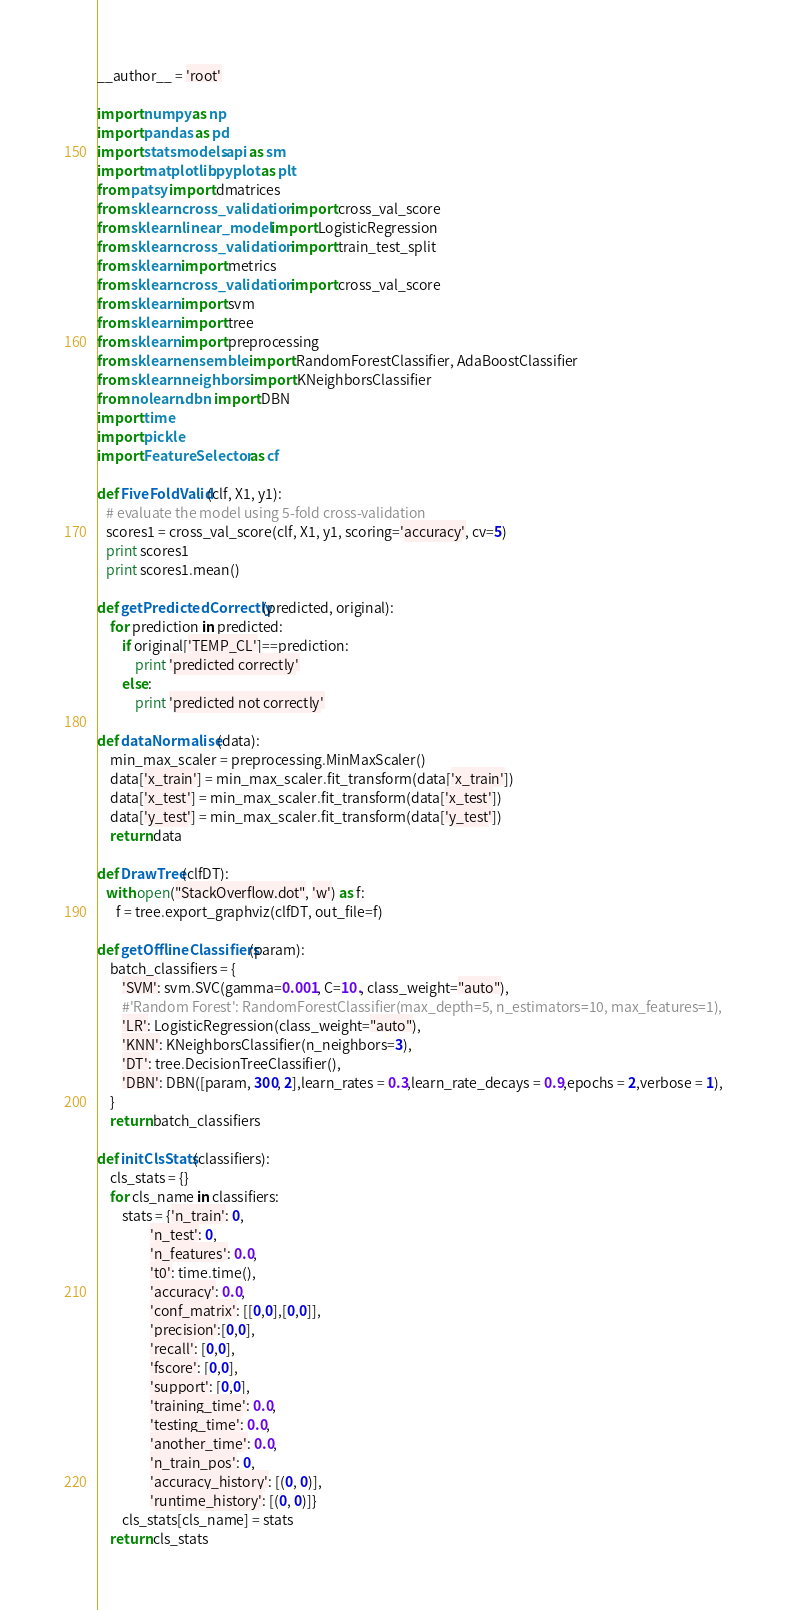Convert code to text. <code><loc_0><loc_0><loc_500><loc_500><_Python_>__author__ = 'root'

import numpy as np
import pandas as pd
import statsmodels.api as sm
import matplotlib.pyplot as plt
from patsy import dmatrices
from sklearn.cross_validation import cross_val_score
from sklearn.linear_model import LogisticRegression
from sklearn.cross_validation import train_test_split
from sklearn import metrics
from sklearn.cross_validation import cross_val_score
from sklearn import svm
from sklearn import tree
from sklearn import preprocessing
from sklearn.ensemble import RandomForestClassifier, AdaBoostClassifier
from sklearn.neighbors import KNeighborsClassifier
from nolearn.dbn import DBN
import time
import pickle
import FeatureSelector as cf

def FiveFoldValid(clf, X1, y1):
   # evaluate the model using 5-fold cross-validation
   scores1 = cross_val_score(clf, X1, y1, scoring='accuracy', cv=5)
   print scores1
   print scores1.mean()

def getPredictedCorrectly(predicted, original):
    for prediction in predicted:
        if original['TEMP_CL']==prediction:
            print 'predicted correctly'
        else:
            print 'predicted not correctly'

def dataNormalise(data):
    min_max_scaler = preprocessing.MinMaxScaler()
    data['x_train'] = min_max_scaler.fit_transform(data['x_train'])
    data['x_test'] = min_max_scaler.fit_transform(data['x_test'])
    data['y_test'] = min_max_scaler.fit_transform(data['y_test'])
    return data

def DrawTree(clfDT):
   with open("StackOverflow.dot", 'w') as f:
      f = tree.export_graphviz(clfDT, out_file=f)

def getOfflineClassifiers(param):
    batch_classifiers = {
        'SVM': svm.SVC(gamma=0.001, C=10., class_weight="auto"),
        #'Random Forest': RandomForestClassifier(max_depth=5, n_estimators=10, max_features=1),
        'LR': LogisticRegression(class_weight="auto"),
        'KNN': KNeighborsClassifier(n_neighbors=3),
        'DT': tree.DecisionTreeClassifier(),
        'DBN': DBN([param, 300, 2],learn_rates = 0.3,learn_rate_decays = 0.9,epochs = 2,verbose = 1),
    }
    return batch_classifiers

def initClsStats(classifiers):
    cls_stats = {}
    for cls_name in classifiers:
        stats = {'n_train': 0,
                 'n_test': 0,
                 'n_features': 0.0,
                 't0': time.time(),
                 'accuracy': 0.0,
                 'conf_matrix': [[0,0],[0,0]],
                 'precision':[0,0],
                 'recall': [0,0],
                 'fscore': [0,0],
                 'support': [0,0],
                 'training_time': 0.0,
                 'testing_time': 0.0,
                 'another_time': 0.0,
                 'n_train_pos': 0,
                 'accuracy_history': [(0, 0)],
                 'runtime_history': [(0, 0)]}
        cls_stats[cls_name] = stats
    return cls_stats
</code> 